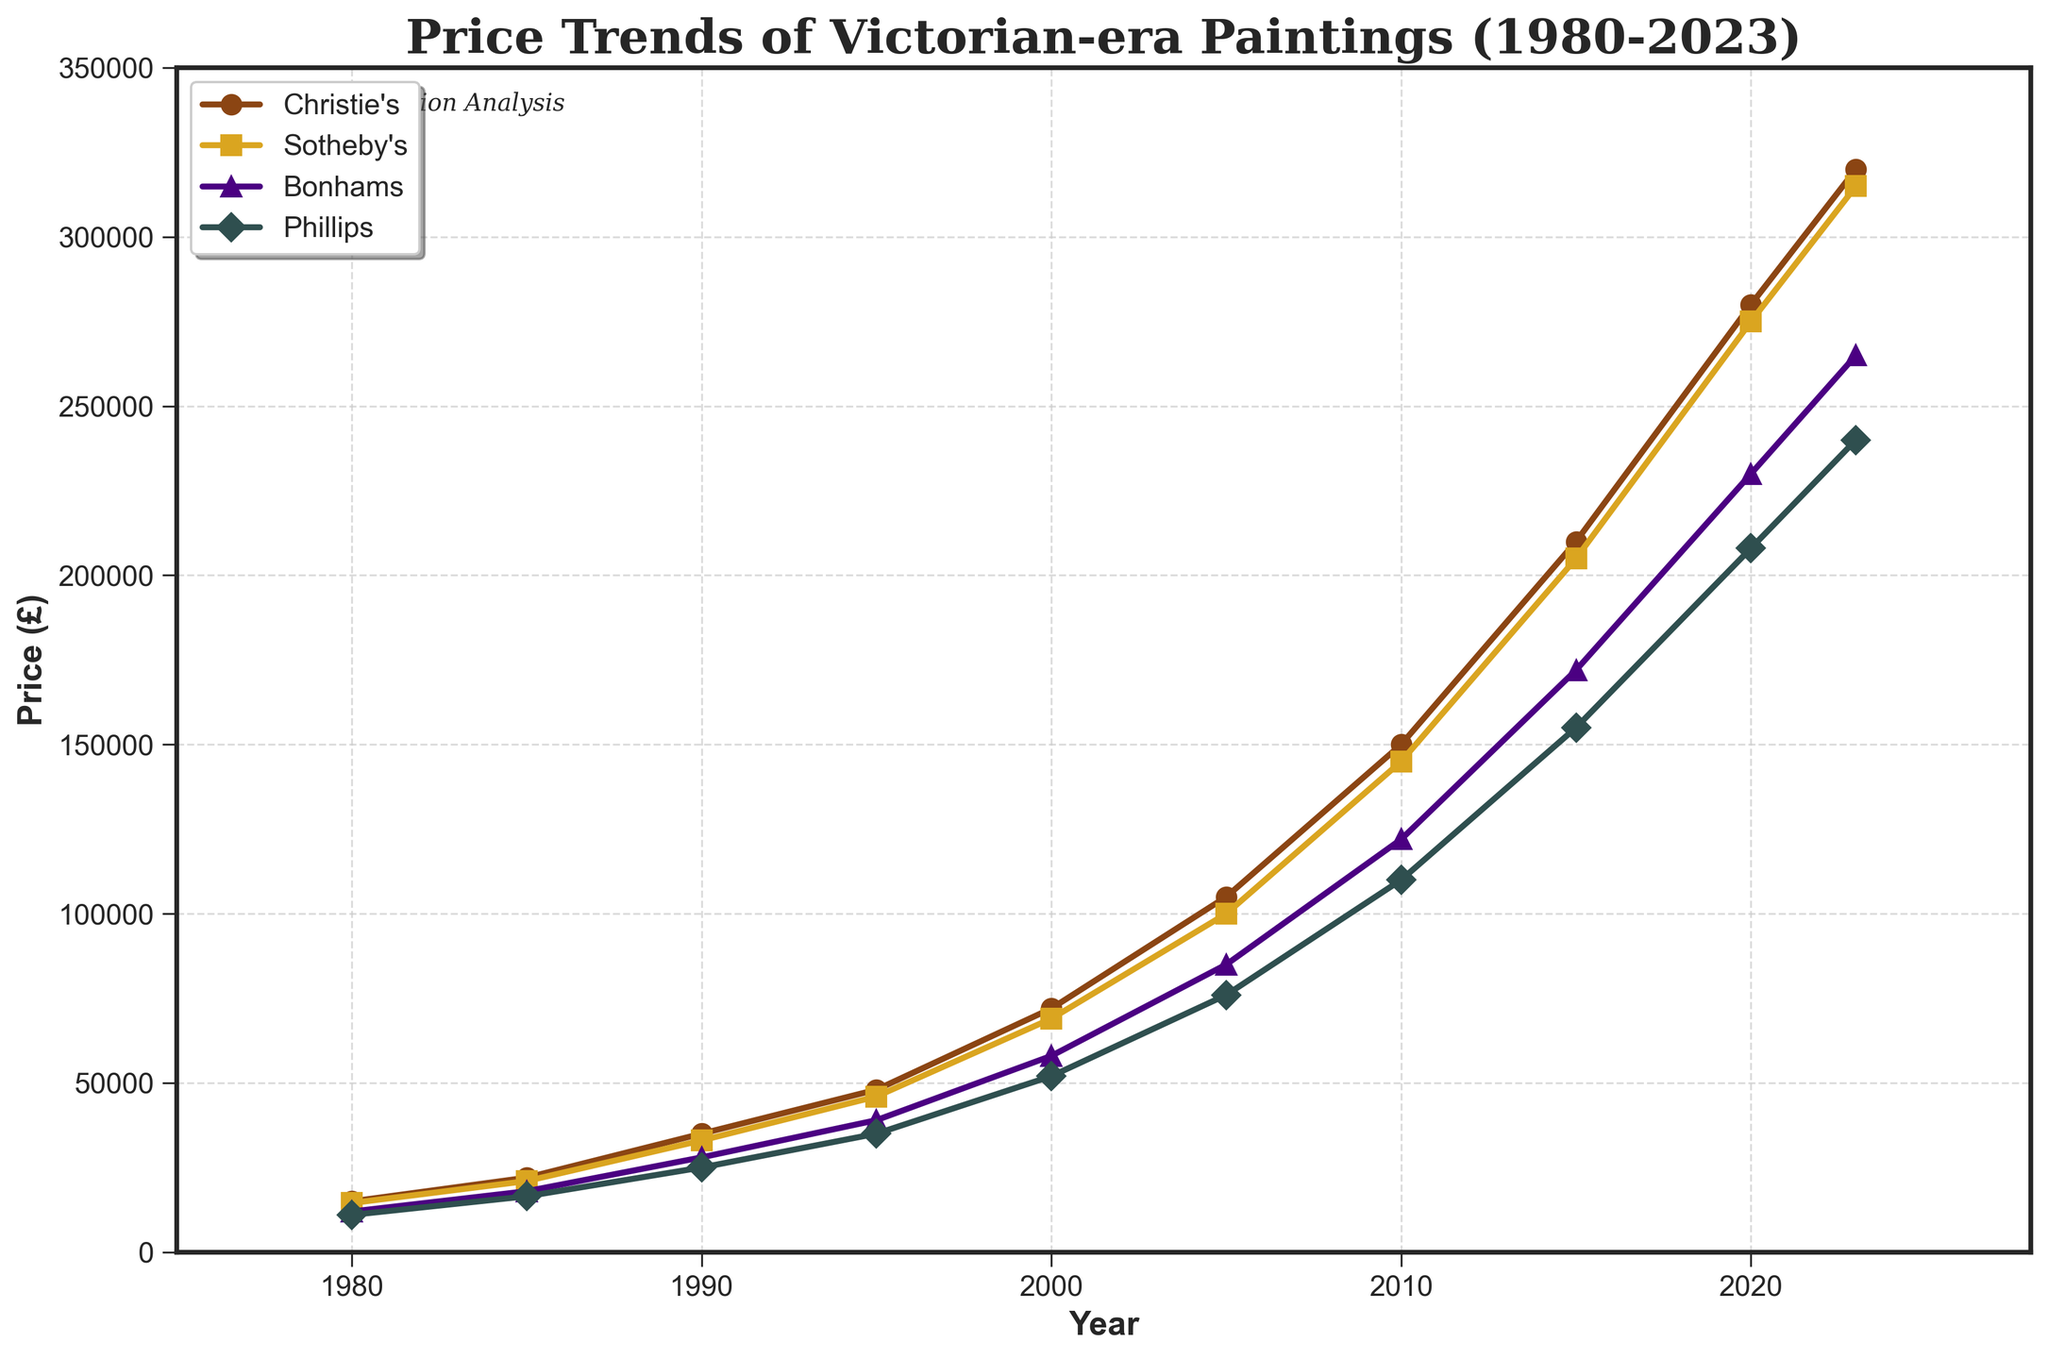What's the average price of Victorian-era paintings at Sotheby's from 2000 to 2023? To find the average price at Sotheby's from 2000 to 2023, sum the prices for the years 2000, 2005, 2010, 2015, 2020, and 2023, then divide by the number of data points: (69000 + 100000 + 145000 + 205000 + 275000 + 315000) / 6 = 2900000 / 6 = 241666.67
Answer: 241666.67 Which auction house had the highest price for Victorian-era paintings in 2015? Look at the prices of all auction houses in 2015. Compare the prices: Christie's (210000), Sotheby's (205000), Bonhams (172000), Phillips (155000). The highest value is 210000 at Christie's.
Answer: Christie's Which auction house showed the greatest increase in price from 1980 to 2023? Calculate the difference from 1980 to 2023 for each auction house:
- Christie's: 320000 - 15000 = 305000
- Sotheby's: 315000 - 14500 = 300500
- Bonhams: 265000 - 12000 = 253000
- Phillips: 240000 - 11000 = 229000
The greatest increase is 305000 at Christie's.
Answer: Christie's How much did the price of Victorian-era paintings increase at Bonhams between 2000 and 2010? Calculate the difference in prices for Bonhams between 2000 and 2010: 122000 - 58000 = 64000
Answer: 64000 In what year did Christie's prices first exceed 200000? Look at the plotted prices for Christie's and identify the first year the value is above 200000. This occurs in 2015 with a price of 210000.
Answer: 2015 Which auction house had the smallest price increase during the 1980 to 1985 period? Calculate the price increases between 1980 and 1985:
- Christie's: 22000 - 15000 = 7000
- Sotheby's: 21000 - 14500 = 6500
- Bonhams: 18000 - 12000 = 6000
- Phillips: 16500 - 11000 = 5500
The smallest price increase is 5500 at Phillips.
Answer: Phillips Compare the price trend of Victorian-era paintings at Christie's and Bonhams from 1995 to 2020. Look at the prices at Christie's and Bonhams in 1995 and 2020 and calculate the differences:
- Christie's: 280000 - 48000 = 232000
- Bonhams: 230000 - 39000 = 191000
Christie's price increased by 232000, while Bonhams increased by 191000, showing a higher increase for Christie's.
Answer: Christie's increased more What was the price difference between Christie's and Phillips in 2023? Subtract Phillips' price from Christie's price in 2023: 320000 - 240000 = 80000
Answer: 80000 Which auction house had the highest price volatility over the period 1980-2023? To determine the auction house with the highest volatility, visually inspect the line plots for which line shows the widest range. Both Christie's and Sotheby's show high volatility, so it's necessary to calculate the range:
- Christie's: 320000 - 15000 = 305000
- Sotheby's: 315000 - 14500 = 300500
- Bonhams: 265000 - 12000 = 253000
- Phillips: 240000 - 11000 = 229000
The highest volatility is in Christie's prices.
Answer: Christie's 